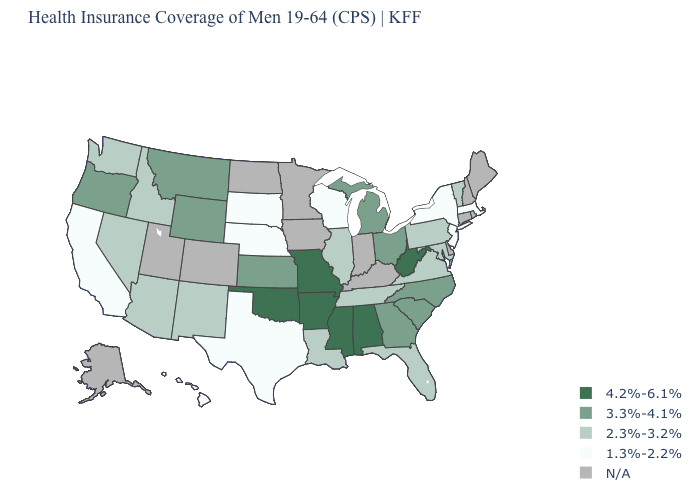Is the legend a continuous bar?
Quick response, please. No. What is the value of Delaware?
Answer briefly. N/A. What is the value of Virginia?
Write a very short answer. 2.3%-3.2%. What is the lowest value in the MidWest?
Concise answer only. 1.3%-2.2%. What is the lowest value in the USA?
Concise answer only. 1.3%-2.2%. What is the value of Georgia?
Short answer required. 3.3%-4.1%. Which states hav the highest value in the South?
Be succinct. Alabama, Arkansas, Mississippi, Oklahoma, West Virginia. Name the states that have a value in the range 3.3%-4.1%?
Quick response, please. Georgia, Kansas, Michigan, Montana, North Carolina, Ohio, Oregon, South Carolina, Wyoming. Which states hav the highest value in the MidWest?
Keep it brief. Missouri. Does Nebraska have the lowest value in the MidWest?
Write a very short answer. Yes. Among the states that border Oklahoma , does Arkansas have the highest value?
Write a very short answer. Yes. What is the value of Maryland?
Answer briefly. 2.3%-3.2%. What is the highest value in states that border Idaho?
Quick response, please. 3.3%-4.1%. Among the states that border California , which have the highest value?
Write a very short answer. Oregon. 